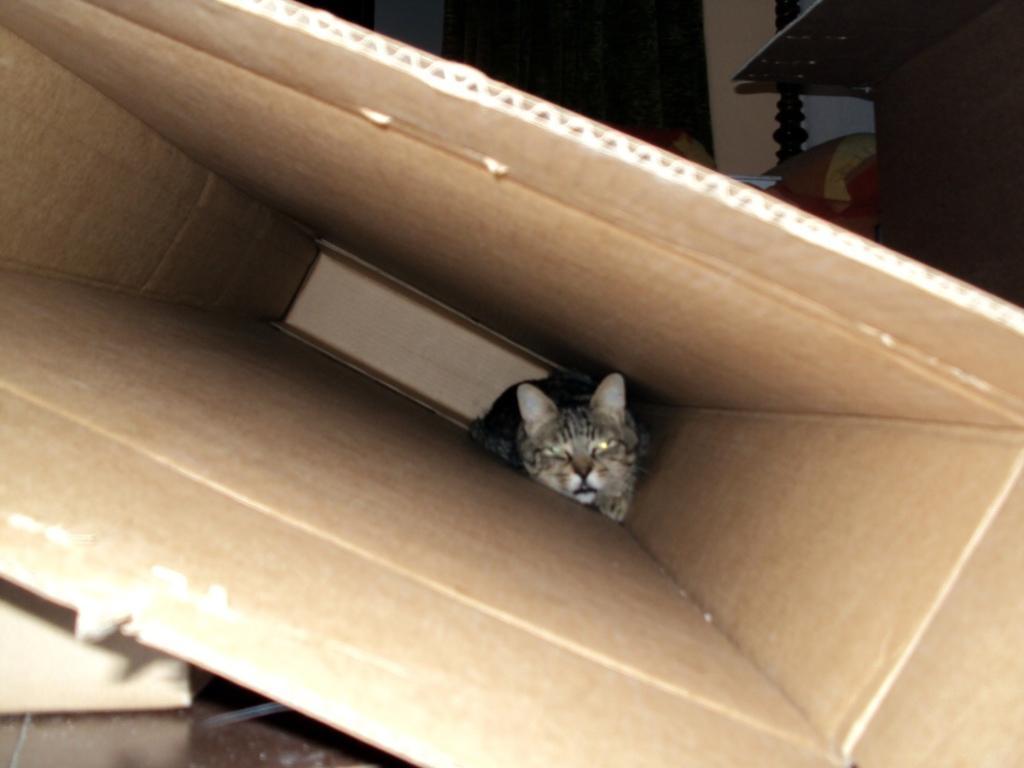Can you describe this image briefly? In this image, we can see a kitten is there inside the carton box. At the bottom, we can see surface. Top of the image, we can see wall, door, cushion, pole. 